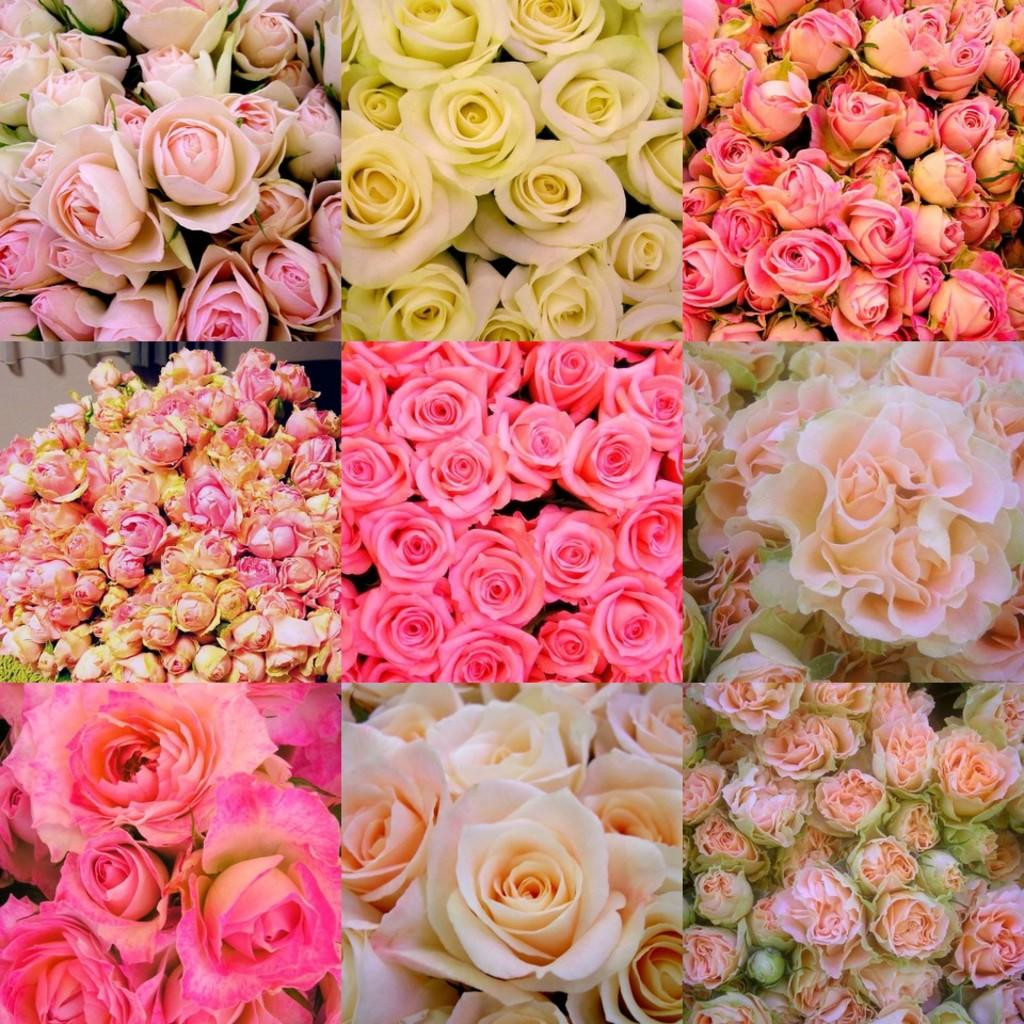How many images are present in the overall picture? There are nine images in the overall picture. What is the common subject in each of the images? Each image contains a rose. Do the roses in the images have the same color? No, the roses in the images have different colors. What type of stick can be seen holding up the roses in the images? There is no stick present in the images; the roses are not being held up by any visible support. 